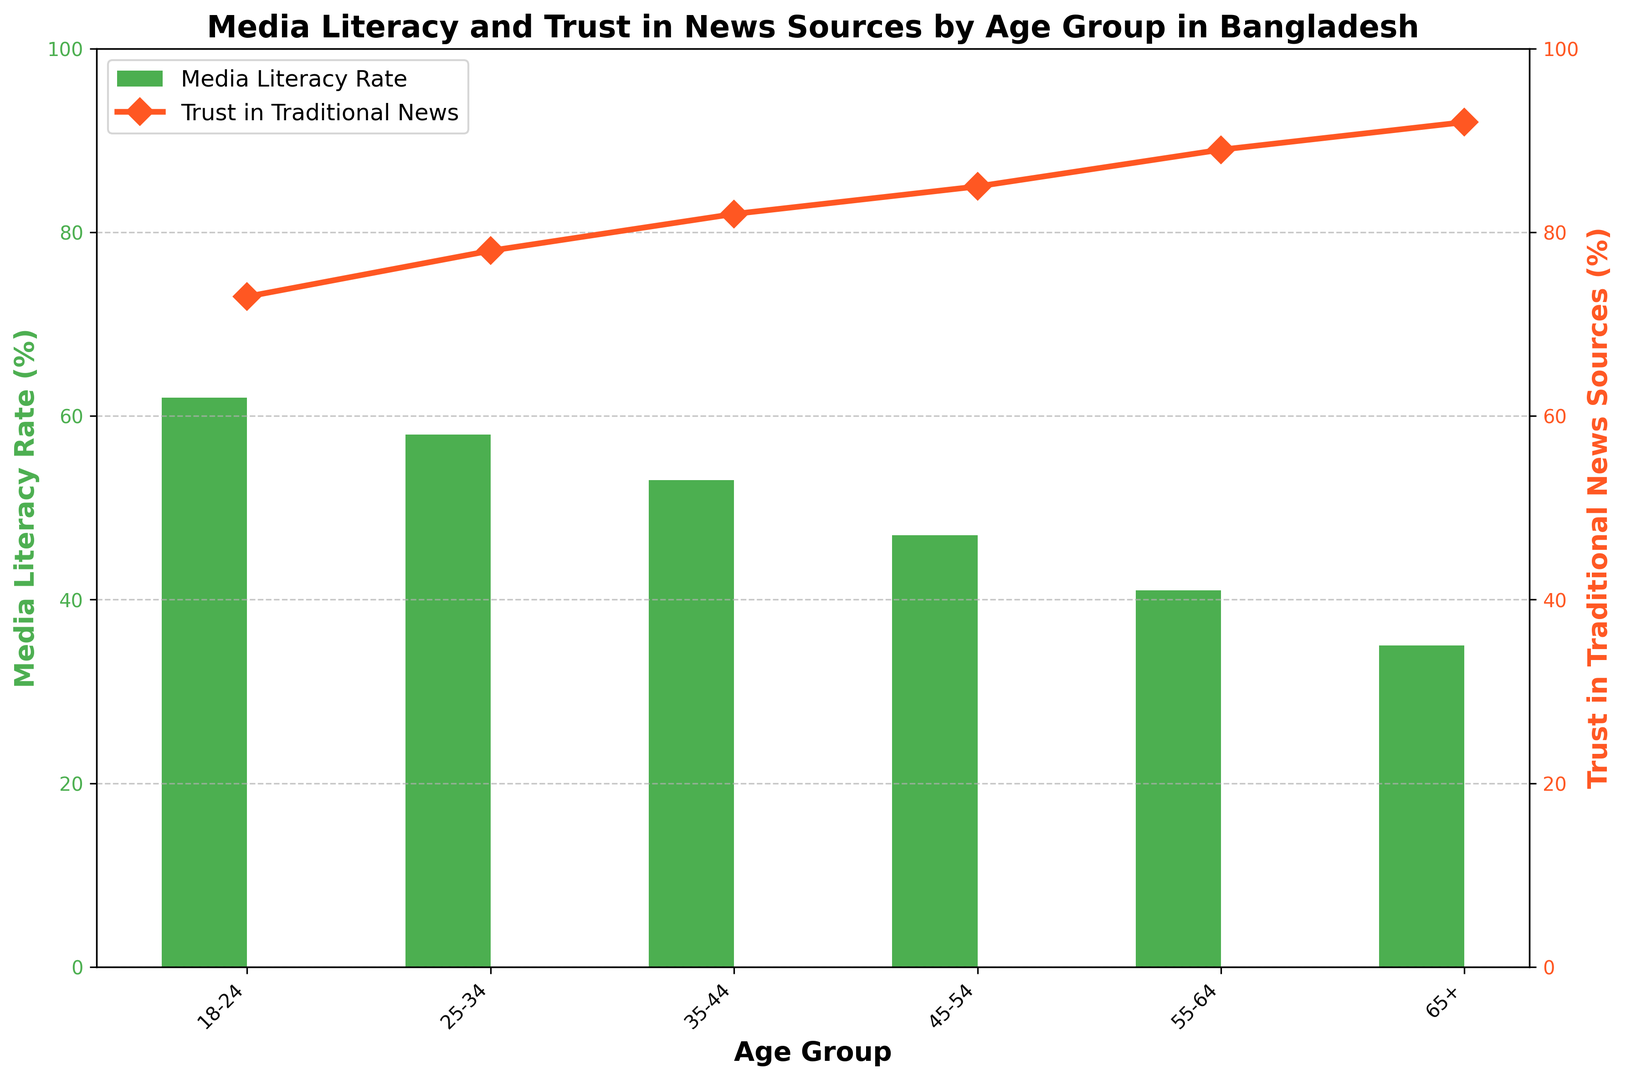What is the media literacy rate for the 18-24 age group? To find the media literacy rate for the 18-24 age group, look at the height of the green bar corresponding to this group.
Answer: 62% Which age group has the highest trust in traditional news sources? Compare the orange line values for all age groups to see which point reaches the highest on the secondary y-axis.
Answer: 65+ How much greater is the trust in traditional news sources for the 55-64 age group compared to the 18-24 age group? Subtract the trust percentage of the 18-24 age group from the trust percentage of the 55-64 age group (89% - 73% = 16%).
Answer: 16% Which age group has the lowest media literacy rate? Compare the height of the green bars for all age groups to find which is the smallest.
Answer: 65+ What is the average media literacy rate for all the age groups? Add up all the media literacy rates and divide by the number of age groups ((62+58+53+47+41+35)/6=49.33).
Answer: 49.33% How does the media literacy rate change as the age increases from 18-24 to 65+? Observe the trend in the green bars from leftmost (18-24) to rightmost (65+). Notice if the values generally increase, decrease, or fluctuate.
Answer: Decrease Is there any age group where the media literacy rate and trust in traditional news sources both are above 60%? Check the green bar (media literacy rate) and the orange point (trust) for each age group to see if both exceed 60%.
Answer: 18-24 On average, which is higher across all age groups: media literacy rate or trust in traditional news sources? Calculate the average for both datasets: (62+58+53+47+41+35)/6 for media literacy rate, and (73+78+82+85+89+92)/6 for trust in news sources. Compare the two averages. Trust in traditional news sources (83.17%) is higher than the media literacy rate (49.33%).
Answer: Trust in traditional news sources Between the age groups 35-44 and 45-54, which one has a higher difference between media literacy rate and trust in traditional news sources? Calculate the differences for each group: 35-44: (82% - 53%) = 29%, 45-54: (85% - 47%) = 38%. Compare the results to determine which difference is larger.
Answer: 45-54 What is the visual difference between the media literacy rate and trust in traditional news sources for the 25-34 age group? Observe the green bar and the orange point for the 25-34 age group. Compare their relative positions on their respective y-axes.
Answer: Media literacy rate (green bar) is lower than trust in traditional news (orange line) 